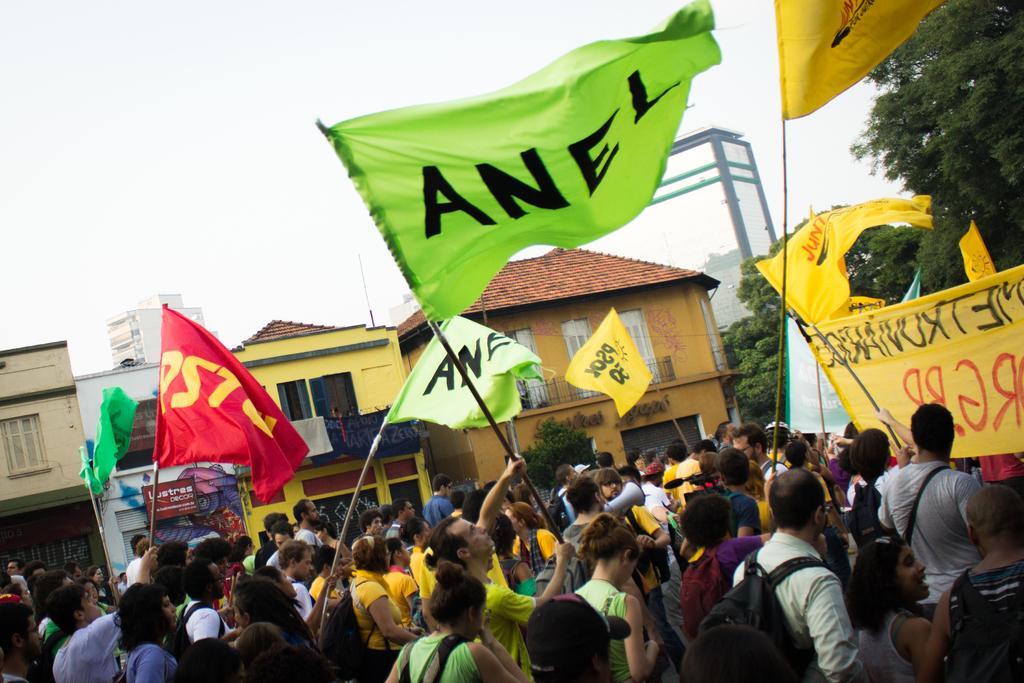In one or two sentences, can you explain what this image depicts? In the picture I can see people are standing and holding the flags. On the right side of the image I can see trees. There is a sky on the top of this image. 